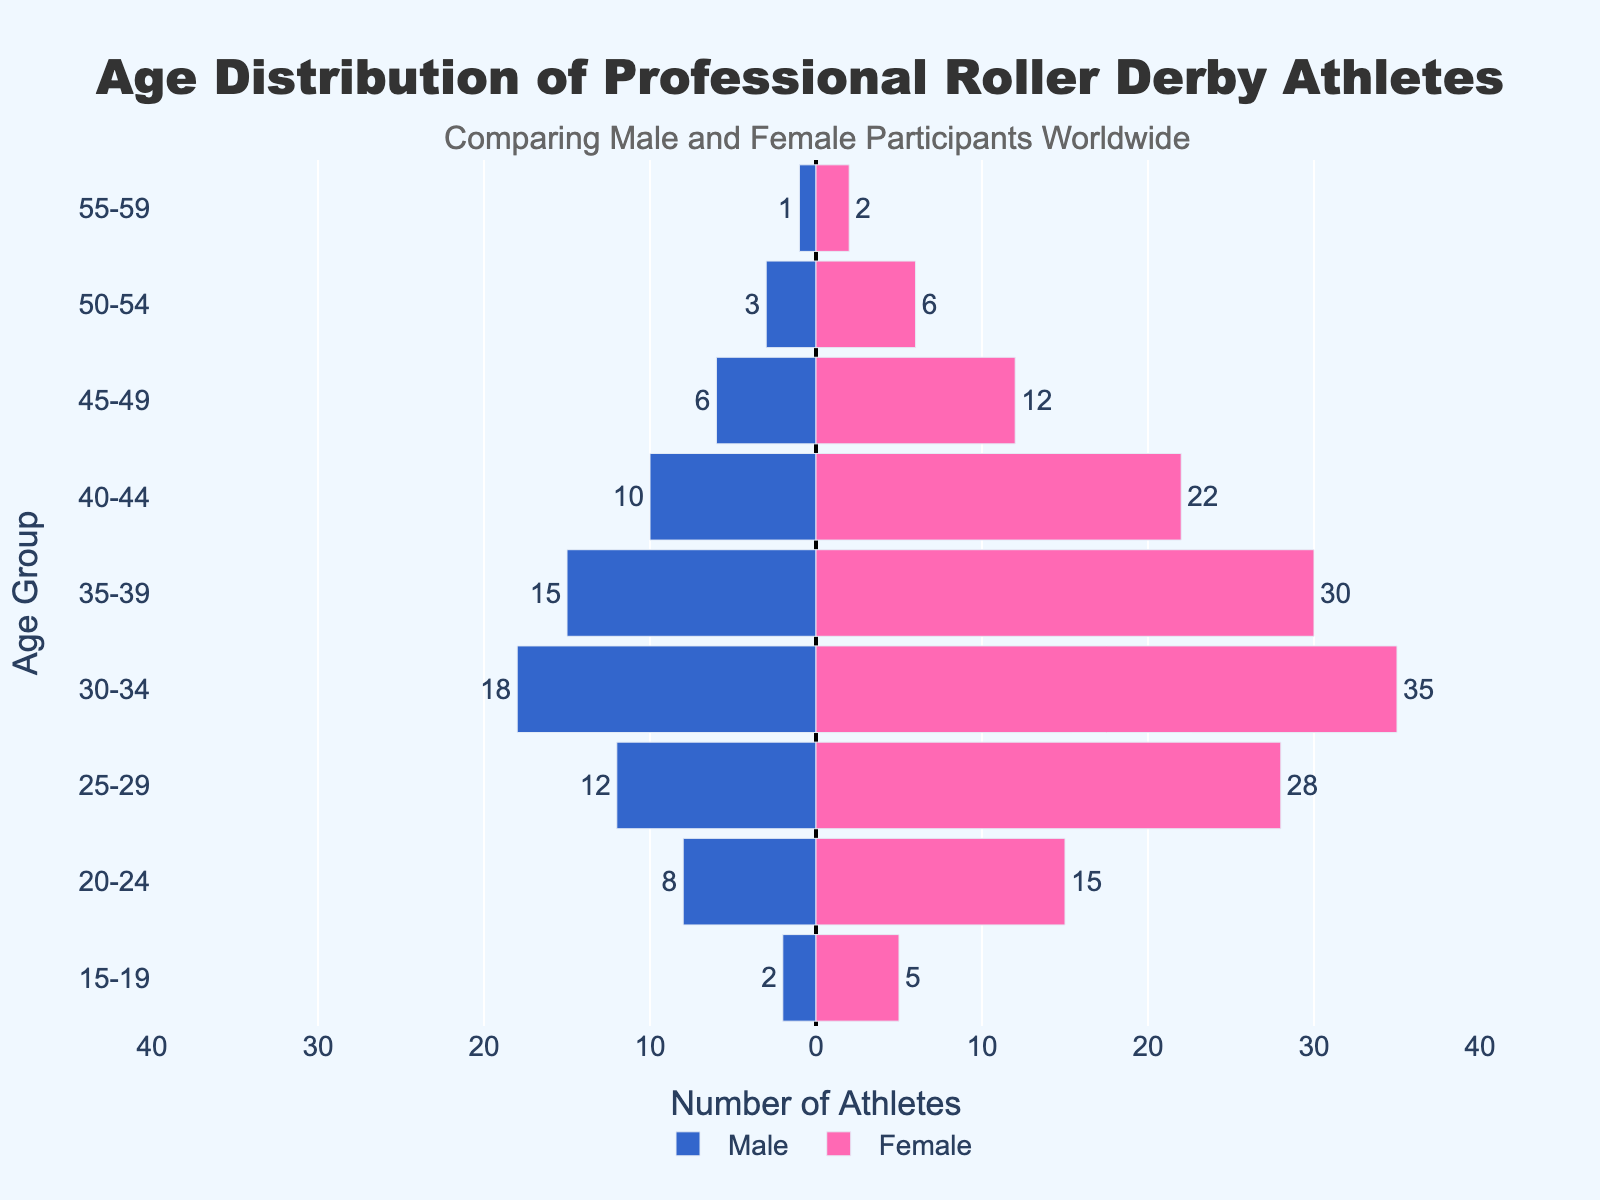What's the title of the figure? The title is usually found at the top of the figure and summarizes what the figure is about.
Answer: "Age Distribution of Professional Roller Derby Athletes" What age group has the highest number of female participants? Check the length of the bars in the "Female" section and find which age group's bar extends the farthest to the right.
Answer: 30-34 How many males are in the 25-29 age group? Check the bar representing the 25-29 age group in the "Male" section, noting that values are negative, and read the value.
Answer: 12 What is the sum of male and female athletes in the 40-44 age group? Add the values of male and female participants in the 40-44 age group.
Answer: 32 Which gender has more athletes in the 35-39 age group and by how much? Compare the lengths of the bars for males and females in the 35-39 age group and subtract the smaller value from the larger value to find the difference.
Answer: Female by 15 What is the trend in participation for males as age increases? Observe the pattern of the bars in the "Male" section from the youngest age group to the oldest age group, noting whether they generally increase, decrease, or remain stable.
Answer: Generally decreases Which age group shows the closest number of participants between males and females? For each age group, compute the absolute difference between male and female participants and identify the smallest value.
Answer: 50-54 What does the color blue represent in the figure? Colors are often described in the legend; find the entry corresponding to the blue bars.
Answer: Male participants What is the age group with the lowest number of male participants? Identify the shortest bar in the "Male" section.
Answer: 55-59 How many more female athletes are there in the 30-34 age group compared to the 50-54 age group? Subtract the number of female athletes in the 50-54 age group from the number in the 30-34 age group.
Answer: 29 